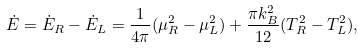<formula> <loc_0><loc_0><loc_500><loc_500>\dot { E } = \dot { E } _ { R } - \dot { E } _ { L } = \frac { 1 } { 4 \pi } ( \mu _ { R } ^ { 2 } - \mu _ { L } ^ { 2 } ) + \frac { \pi k _ { B } ^ { 2 } } { 1 2 } ( T _ { R } ^ { 2 } - T _ { L } ^ { 2 } ) ,</formula> 